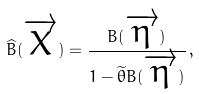Convert formula to latex. <formula><loc_0><loc_0><loc_500><loc_500>\widehat { B } ( \overrightarrow { X } ) = \frac { B ( \overrightarrow { \eta } ) } { 1 - \widetilde { \theta } B ( \overrightarrow { \eta } ) } \, ,</formula> 